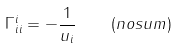Convert formula to latex. <formula><loc_0><loc_0><loc_500><loc_500>\Gamma _ { i i } ^ { i } = - \frac { 1 } { u _ { i } } \quad ( n o s u m )</formula> 